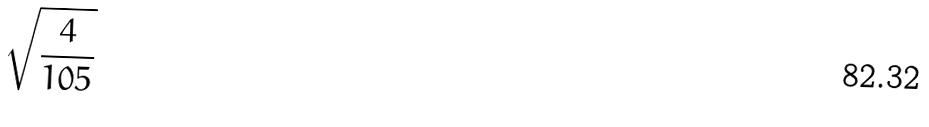Convert formula to latex. <formula><loc_0><loc_0><loc_500><loc_500>\sqrt { \frac { 4 } { 1 0 5 } }</formula> 